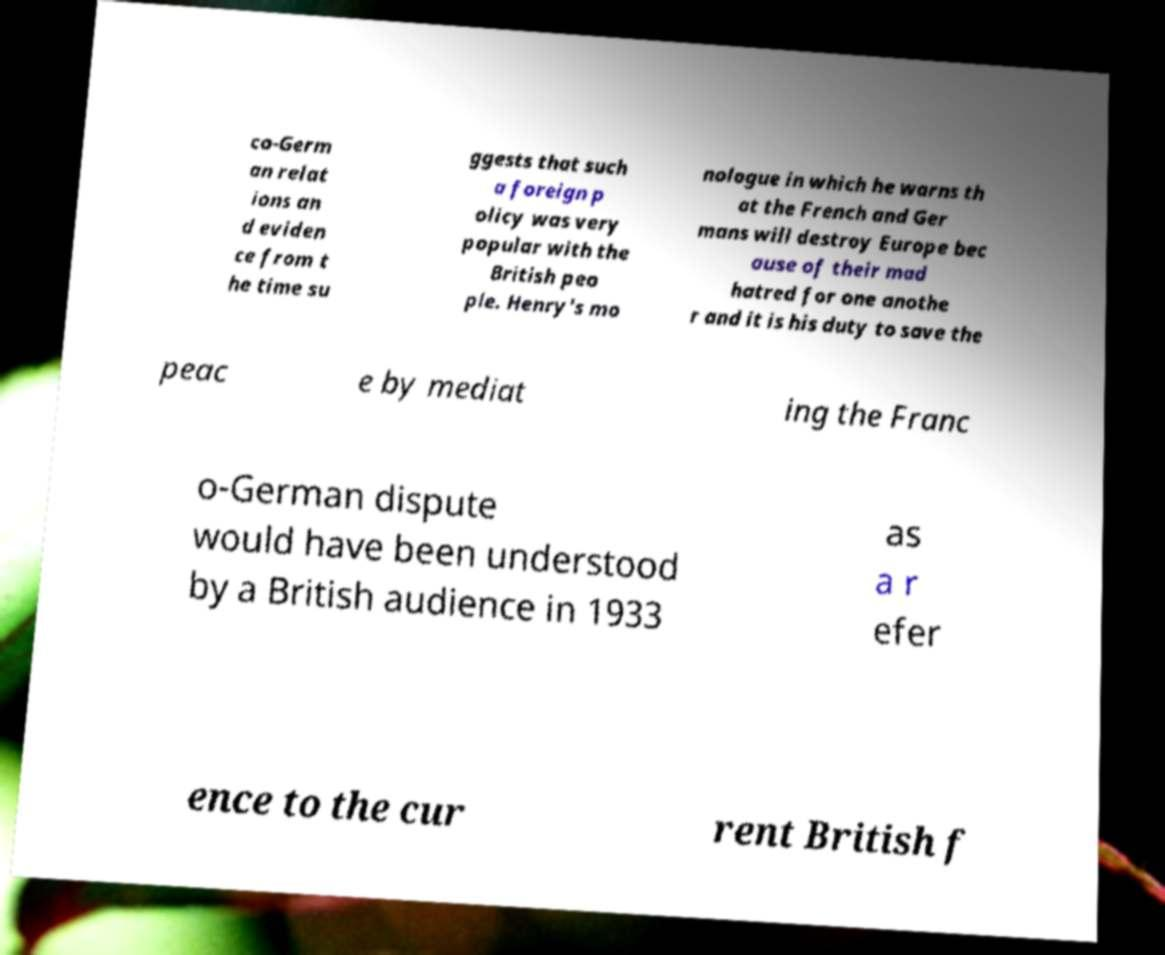What messages or text are displayed in this image? I need them in a readable, typed format. co-Germ an relat ions an d eviden ce from t he time su ggests that such a foreign p olicy was very popular with the British peo ple. Henry's mo nologue in which he warns th at the French and Ger mans will destroy Europe bec ause of their mad hatred for one anothe r and it is his duty to save the peac e by mediat ing the Franc o-German dispute would have been understood by a British audience in 1933 as a r efer ence to the cur rent British f 